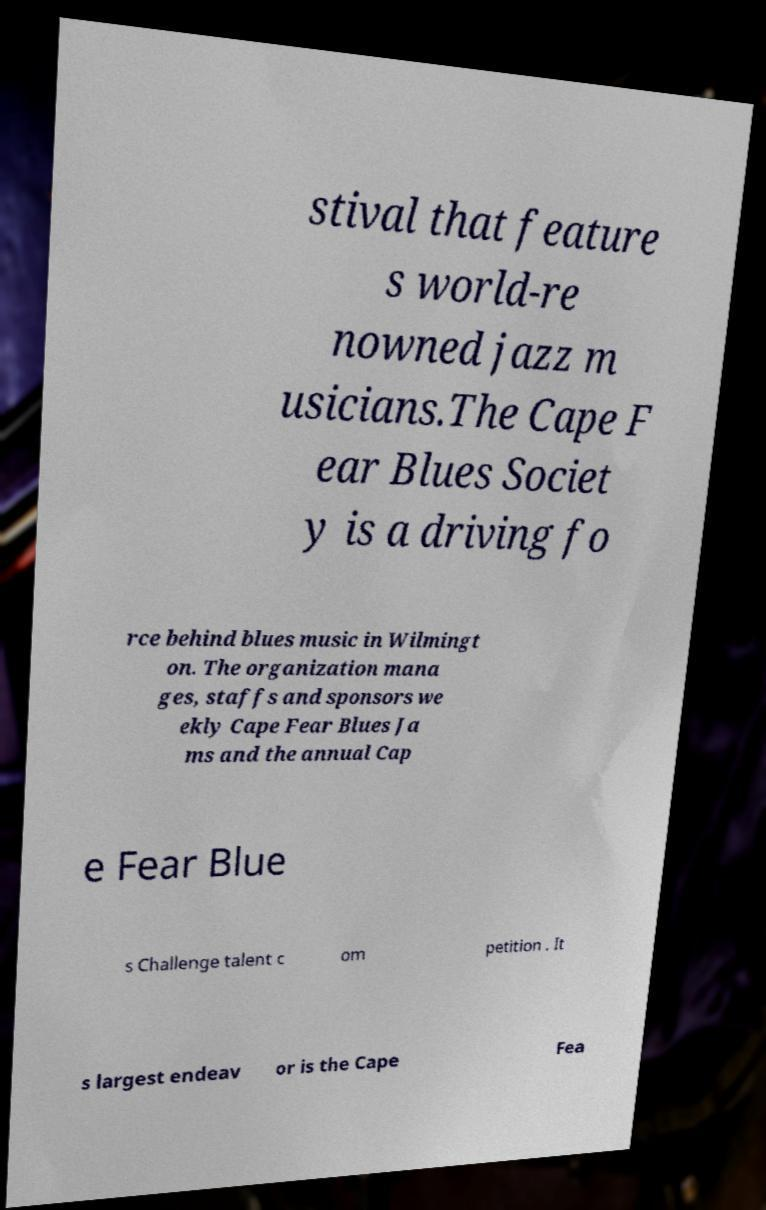Could you extract and type out the text from this image? stival that feature s world-re nowned jazz m usicians.The Cape F ear Blues Societ y is a driving fo rce behind blues music in Wilmingt on. The organization mana ges, staffs and sponsors we ekly Cape Fear Blues Ja ms and the annual Cap e Fear Blue s Challenge talent c om petition . It s largest endeav or is the Cape Fea 